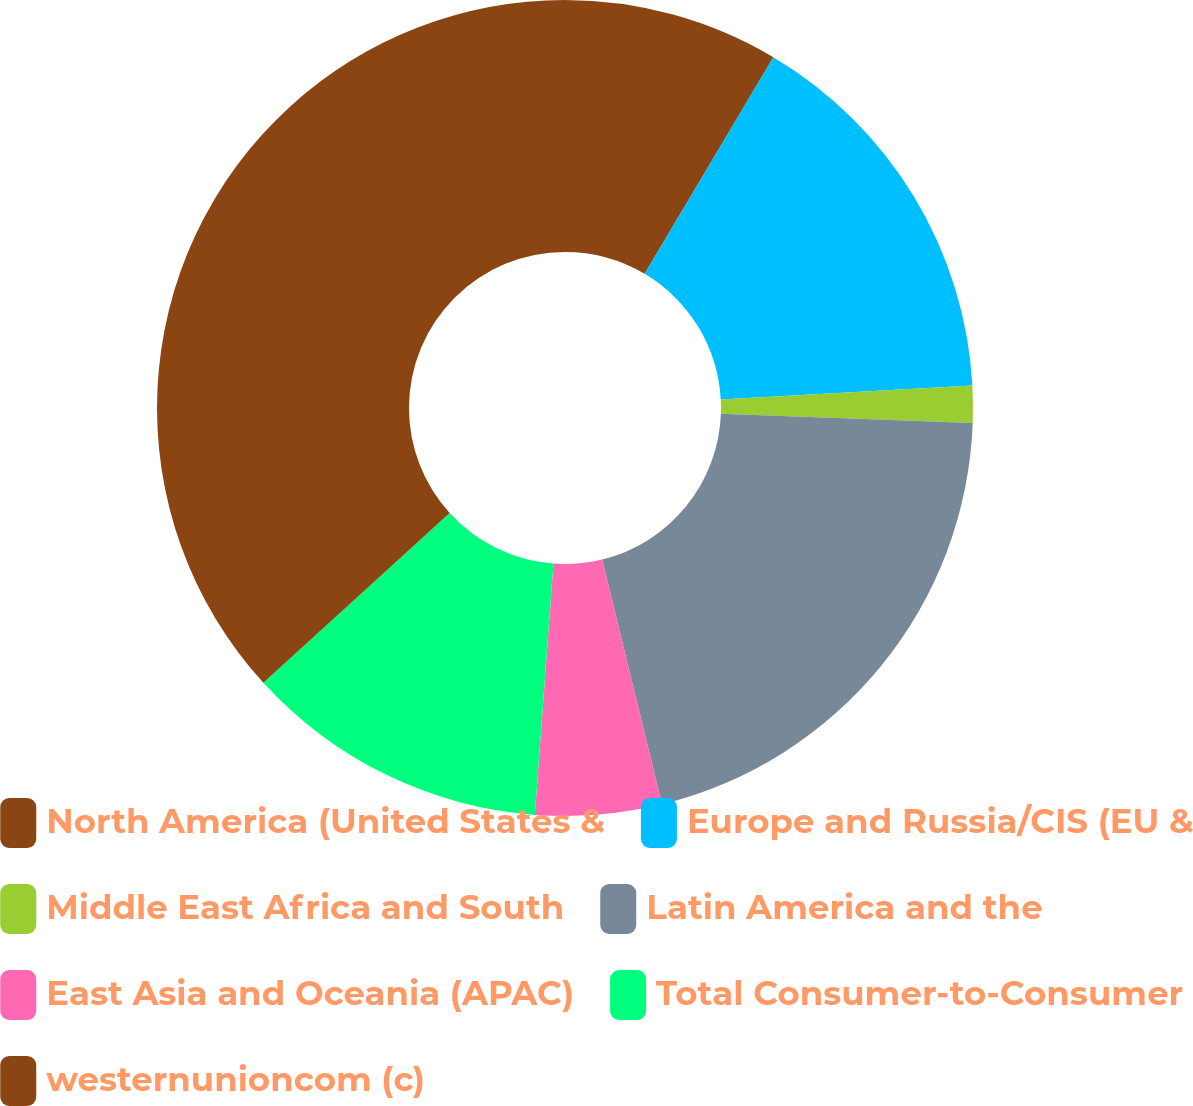Convert chart to OTSL. <chart><loc_0><loc_0><loc_500><loc_500><pie_chart><fcel>North America (United States &<fcel>Europe and Russia/CIS (EU &<fcel>Middle East Africa and South<fcel>Latin America and the<fcel>East Asia and Oceania (APAC)<fcel>Total Consumer-to-Consumer<fcel>westernunioncom (c)<nl><fcel>8.53%<fcel>15.59%<fcel>1.47%<fcel>20.59%<fcel>5.0%<fcel>12.06%<fcel>36.76%<nl></chart> 